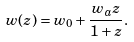<formula> <loc_0><loc_0><loc_500><loc_500>w ( z ) = w _ { 0 } + \frac { w _ { a } z } { 1 + z } .</formula> 